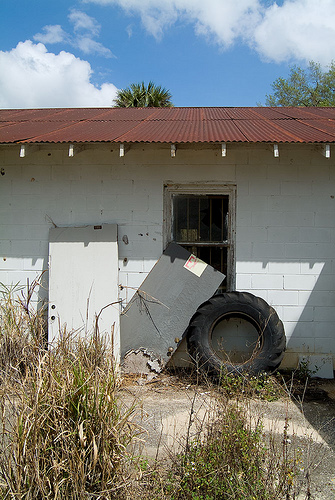<image>
Can you confirm if the wheel is under the roof? Yes. The wheel is positioned underneath the roof, with the roof above it in the vertical space. Is there a door on the tractor tire? Yes. Looking at the image, I can see the door is positioned on top of the tractor tire, with the tractor tire providing support. 